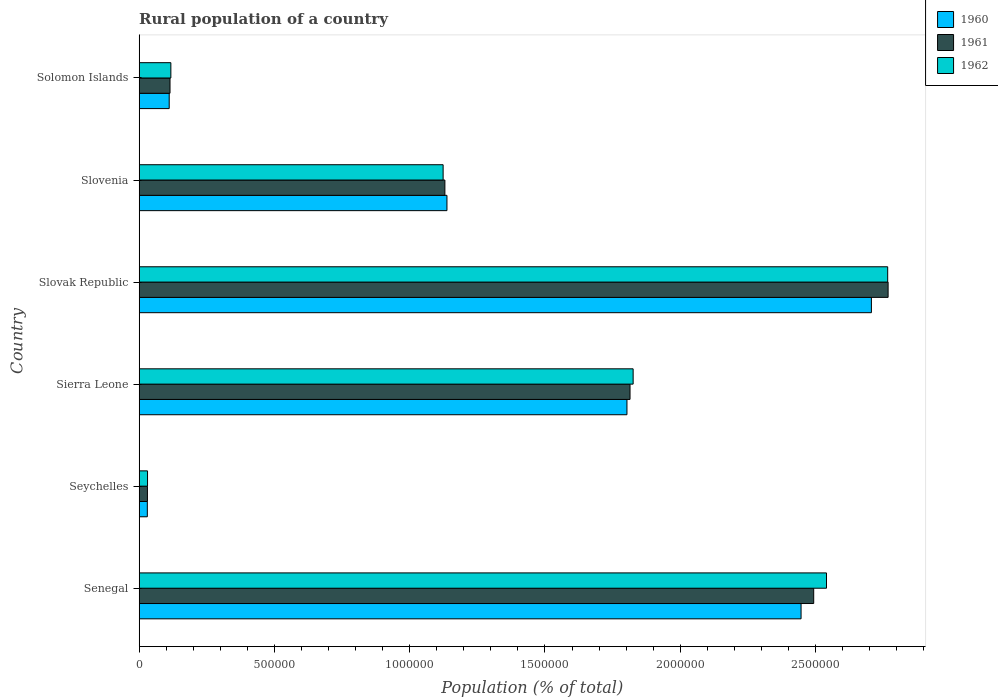Are the number of bars per tick equal to the number of legend labels?
Offer a very short reply. Yes. How many bars are there on the 1st tick from the top?
Your response must be concise. 3. How many bars are there on the 2nd tick from the bottom?
Provide a short and direct response. 3. What is the label of the 4th group of bars from the top?
Offer a terse response. Sierra Leone. What is the rural population in 1961 in Sierra Leone?
Make the answer very short. 1.81e+06. Across all countries, what is the maximum rural population in 1961?
Your response must be concise. 2.77e+06. Across all countries, what is the minimum rural population in 1960?
Provide a succinct answer. 3.02e+04. In which country was the rural population in 1961 maximum?
Your answer should be compact. Slovak Republic. In which country was the rural population in 1961 minimum?
Your response must be concise. Seychelles. What is the total rural population in 1961 in the graph?
Provide a short and direct response. 8.35e+06. What is the difference between the rural population in 1962 in Seychelles and that in Slovak Republic?
Provide a short and direct response. -2.74e+06. What is the difference between the rural population in 1961 in Slovak Republic and the rural population in 1962 in Solomon Islands?
Offer a very short reply. 2.65e+06. What is the average rural population in 1960 per country?
Your answer should be compact. 1.37e+06. What is the difference between the rural population in 1961 and rural population in 1962 in Sierra Leone?
Your answer should be very brief. -1.15e+04. In how many countries, is the rural population in 1960 greater than 2700000 %?
Your response must be concise. 1. What is the ratio of the rural population in 1961 in Seychelles to that in Sierra Leone?
Keep it short and to the point. 0.02. Is the rural population in 1961 in Senegal less than that in Slovenia?
Provide a succinct answer. No. Is the difference between the rural population in 1961 in Senegal and Solomon Islands greater than the difference between the rural population in 1962 in Senegal and Solomon Islands?
Offer a very short reply. No. What is the difference between the highest and the second highest rural population in 1961?
Your response must be concise. 2.75e+05. What is the difference between the highest and the lowest rural population in 1961?
Provide a succinct answer. 2.74e+06. In how many countries, is the rural population in 1961 greater than the average rural population in 1961 taken over all countries?
Your answer should be compact. 3. Is it the case that in every country, the sum of the rural population in 1961 and rural population in 1960 is greater than the rural population in 1962?
Make the answer very short. Yes. Are all the bars in the graph horizontal?
Provide a short and direct response. Yes. How many countries are there in the graph?
Make the answer very short. 6. What is the difference between two consecutive major ticks on the X-axis?
Your answer should be very brief. 5.00e+05. Does the graph contain grids?
Your response must be concise. No. Where does the legend appear in the graph?
Your answer should be compact. Top right. What is the title of the graph?
Your answer should be compact. Rural population of a country. What is the label or title of the X-axis?
Ensure brevity in your answer.  Population (% of total). What is the label or title of the Y-axis?
Your response must be concise. Country. What is the Population (% of total) of 1960 in Senegal?
Offer a terse response. 2.45e+06. What is the Population (% of total) in 1961 in Senegal?
Offer a very short reply. 2.49e+06. What is the Population (% of total) in 1962 in Senegal?
Provide a succinct answer. 2.54e+06. What is the Population (% of total) of 1960 in Seychelles?
Keep it short and to the point. 3.02e+04. What is the Population (% of total) of 1961 in Seychelles?
Ensure brevity in your answer.  3.06e+04. What is the Population (% of total) in 1962 in Seychelles?
Offer a very short reply. 3.09e+04. What is the Population (% of total) of 1960 in Sierra Leone?
Your answer should be very brief. 1.80e+06. What is the Population (% of total) in 1961 in Sierra Leone?
Your answer should be very brief. 1.81e+06. What is the Population (% of total) in 1962 in Sierra Leone?
Make the answer very short. 1.83e+06. What is the Population (% of total) in 1960 in Slovak Republic?
Offer a terse response. 2.71e+06. What is the Population (% of total) in 1961 in Slovak Republic?
Your answer should be compact. 2.77e+06. What is the Population (% of total) in 1962 in Slovak Republic?
Offer a terse response. 2.77e+06. What is the Population (% of total) of 1960 in Slovenia?
Make the answer very short. 1.14e+06. What is the Population (% of total) of 1961 in Slovenia?
Keep it short and to the point. 1.13e+06. What is the Population (% of total) in 1962 in Slovenia?
Provide a succinct answer. 1.12e+06. What is the Population (% of total) of 1960 in Solomon Islands?
Your answer should be compact. 1.11e+05. What is the Population (% of total) in 1961 in Solomon Islands?
Provide a short and direct response. 1.14e+05. What is the Population (% of total) of 1962 in Solomon Islands?
Give a very brief answer. 1.17e+05. Across all countries, what is the maximum Population (% of total) of 1960?
Give a very brief answer. 2.71e+06. Across all countries, what is the maximum Population (% of total) of 1961?
Make the answer very short. 2.77e+06. Across all countries, what is the maximum Population (% of total) of 1962?
Your answer should be compact. 2.77e+06. Across all countries, what is the minimum Population (% of total) in 1960?
Provide a short and direct response. 3.02e+04. Across all countries, what is the minimum Population (% of total) of 1961?
Offer a terse response. 3.06e+04. Across all countries, what is the minimum Population (% of total) of 1962?
Offer a very short reply. 3.09e+04. What is the total Population (% of total) in 1960 in the graph?
Offer a very short reply. 8.24e+06. What is the total Population (% of total) of 1961 in the graph?
Offer a very short reply. 8.35e+06. What is the total Population (% of total) in 1962 in the graph?
Your answer should be very brief. 8.41e+06. What is the difference between the Population (% of total) of 1960 in Senegal and that in Seychelles?
Provide a short and direct response. 2.42e+06. What is the difference between the Population (% of total) in 1961 in Senegal and that in Seychelles?
Offer a very short reply. 2.46e+06. What is the difference between the Population (% of total) of 1962 in Senegal and that in Seychelles?
Your answer should be compact. 2.51e+06. What is the difference between the Population (% of total) of 1960 in Senegal and that in Sierra Leone?
Your answer should be compact. 6.44e+05. What is the difference between the Population (% of total) in 1961 in Senegal and that in Sierra Leone?
Your answer should be compact. 6.79e+05. What is the difference between the Population (% of total) in 1962 in Senegal and that in Sierra Leone?
Your response must be concise. 7.15e+05. What is the difference between the Population (% of total) in 1960 in Senegal and that in Slovak Republic?
Offer a terse response. -2.60e+05. What is the difference between the Population (% of total) in 1961 in Senegal and that in Slovak Republic?
Offer a very short reply. -2.75e+05. What is the difference between the Population (% of total) in 1962 in Senegal and that in Slovak Republic?
Offer a terse response. -2.26e+05. What is the difference between the Population (% of total) in 1960 in Senegal and that in Slovenia?
Offer a very short reply. 1.31e+06. What is the difference between the Population (% of total) in 1961 in Senegal and that in Slovenia?
Provide a succinct answer. 1.36e+06. What is the difference between the Population (% of total) in 1962 in Senegal and that in Slovenia?
Offer a terse response. 1.42e+06. What is the difference between the Population (% of total) in 1960 in Senegal and that in Solomon Islands?
Provide a succinct answer. 2.34e+06. What is the difference between the Population (% of total) of 1961 in Senegal and that in Solomon Islands?
Give a very brief answer. 2.38e+06. What is the difference between the Population (% of total) of 1962 in Senegal and that in Solomon Islands?
Give a very brief answer. 2.42e+06. What is the difference between the Population (% of total) of 1960 in Seychelles and that in Sierra Leone?
Offer a terse response. -1.77e+06. What is the difference between the Population (% of total) in 1961 in Seychelles and that in Sierra Leone?
Your response must be concise. -1.78e+06. What is the difference between the Population (% of total) in 1962 in Seychelles and that in Sierra Leone?
Your answer should be very brief. -1.80e+06. What is the difference between the Population (% of total) of 1960 in Seychelles and that in Slovak Republic?
Your answer should be very brief. -2.68e+06. What is the difference between the Population (% of total) in 1961 in Seychelles and that in Slovak Republic?
Provide a short and direct response. -2.74e+06. What is the difference between the Population (% of total) in 1962 in Seychelles and that in Slovak Republic?
Your answer should be very brief. -2.74e+06. What is the difference between the Population (% of total) in 1960 in Seychelles and that in Slovenia?
Offer a terse response. -1.11e+06. What is the difference between the Population (% of total) in 1961 in Seychelles and that in Slovenia?
Your answer should be very brief. -1.10e+06. What is the difference between the Population (% of total) of 1962 in Seychelles and that in Slovenia?
Your answer should be compact. -1.09e+06. What is the difference between the Population (% of total) in 1960 in Seychelles and that in Solomon Islands?
Ensure brevity in your answer.  -8.09e+04. What is the difference between the Population (% of total) in 1961 in Seychelles and that in Solomon Islands?
Your answer should be compact. -8.35e+04. What is the difference between the Population (% of total) in 1962 in Seychelles and that in Solomon Islands?
Ensure brevity in your answer.  -8.62e+04. What is the difference between the Population (% of total) in 1960 in Sierra Leone and that in Slovak Republic?
Your answer should be very brief. -9.04e+05. What is the difference between the Population (% of total) in 1961 in Sierra Leone and that in Slovak Republic?
Provide a succinct answer. -9.54e+05. What is the difference between the Population (% of total) of 1962 in Sierra Leone and that in Slovak Republic?
Ensure brevity in your answer.  -9.41e+05. What is the difference between the Population (% of total) in 1960 in Sierra Leone and that in Slovenia?
Offer a terse response. 6.65e+05. What is the difference between the Population (% of total) of 1961 in Sierra Leone and that in Slovenia?
Your response must be concise. 6.84e+05. What is the difference between the Population (% of total) in 1962 in Sierra Leone and that in Slovenia?
Make the answer very short. 7.02e+05. What is the difference between the Population (% of total) of 1960 in Sierra Leone and that in Solomon Islands?
Your response must be concise. 1.69e+06. What is the difference between the Population (% of total) of 1961 in Sierra Leone and that in Solomon Islands?
Offer a terse response. 1.70e+06. What is the difference between the Population (% of total) in 1962 in Sierra Leone and that in Solomon Islands?
Ensure brevity in your answer.  1.71e+06. What is the difference between the Population (% of total) in 1960 in Slovak Republic and that in Slovenia?
Give a very brief answer. 1.57e+06. What is the difference between the Population (% of total) in 1961 in Slovak Republic and that in Slovenia?
Your response must be concise. 1.64e+06. What is the difference between the Population (% of total) in 1962 in Slovak Republic and that in Slovenia?
Provide a short and direct response. 1.64e+06. What is the difference between the Population (% of total) in 1960 in Slovak Republic and that in Solomon Islands?
Make the answer very short. 2.60e+06. What is the difference between the Population (% of total) of 1961 in Slovak Republic and that in Solomon Islands?
Make the answer very short. 2.65e+06. What is the difference between the Population (% of total) of 1962 in Slovak Republic and that in Solomon Islands?
Ensure brevity in your answer.  2.65e+06. What is the difference between the Population (% of total) of 1960 in Slovenia and that in Solomon Islands?
Provide a succinct answer. 1.03e+06. What is the difference between the Population (% of total) in 1961 in Slovenia and that in Solomon Islands?
Provide a short and direct response. 1.02e+06. What is the difference between the Population (% of total) in 1962 in Slovenia and that in Solomon Islands?
Keep it short and to the point. 1.01e+06. What is the difference between the Population (% of total) in 1960 in Senegal and the Population (% of total) in 1961 in Seychelles?
Your answer should be compact. 2.42e+06. What is the difference between the Population (% of total) in 1960 in Senegal and the Population (% of total) in 1962 in Seychelles?
Keep it short and to the point. 2.42e+06. What is the difference between the Population (% of total) of 1961 in Senegal and the Population (% of total) of 1962 in Seychelles?
Keep it short and to the point. 2.46e+06. What is the difference between the Population (% of total) in 1960 in Senegal and the Population (% of total) in 1961 in Sierra Leone?
Keep it short and to the point. 6.32e+05. What is the difference between the Population (% of total) of 1960 in Senegal and the Population (% of total) of 1962 in Sierra Leone?
Offer a very short reply. 6.21e+05. What is the difference between the Population (% of total) in 1961 in Senegal and the Population (% of total) in 1962 in Sierra Leone?
Your answer should be compact. 6.67e+05. What is the difference between the Population (% of total) of 1960 in Senegal and the Population (% of total) of 1961 in Slovak Republic?
Your response must be concise. -3.22e+05. What is the difference between the Population (% of total) of 1960 in Senegal and the Population (% of total) of 1962 in Slovak Republic?
Give a very brief answer. -3.20e+05. What is the difference between the Population (% of total) of 1961 in Senegal and the Population (% of total) of 1962 in Slovak Republic?
Ensure brevity in your answer.  -2.74e+05. What is the difference between the Population (% of total) in 1960 in Senegal and the Population (% of total) in 1961 in Slovenia?
Your answer should be compact. 1.32e+06. What is the difference between the Population (% of total) in 1960 in Senegal and the Population (% of total) in 1962 in Slovenia?
Make the answer very short. 1.32e+06. What is the difference between the Population (% of total) of 1961 in Senegal and the Population (% of total) of 1962 in Slovenia?
Offer a very short reply. 1.37e+06. What is the difference between the Population (% of total) in 1960 in Senegal and the Population (% of total) in 1961 in Solomon Islands?
Provide a succinct answer. 2.33e+06. What is the difference between the Population (% of total) in 1960 in Senegal and the Population (% of total) in 1962 in Solomon Islands?
Provide a short and direct response. 2.33e+06. What is the difference between the Population (% of total) in 1961 in Senegal and the Population (% of total) in 1962 in Solomon Islands?
Provide a short and direct response. 2.38e+06. What is the difference between the Population (% of total) of 1960 in Seychelles and the Population (% of total) of 1961 in Sierra Leone?
Keep it short and to the point. -1.78e+06. What is the difference between the Population (% of total) of 1960 in Seychelles and the Population (% of total) of 1962 in Sierra Leone?
Your answer should be compact. -1.80e+06. What is the difference between the Population (% of total) in 1961 in Seychelles and the Population (% of total) in 1962 in Sierra Leone?
Offer a very short reply. -1.80e+06. What is the difference between the Population (% of total) of 1960 in Seychelles and the Population (% of total) of 1961 in Slovak Republic?
Ensure brevity in your answer.  -2.74e+06. What is the difference between the Population (% of total) in 1960 in Seychelles and the Population (% of total) in 1962 in Slovak Republic?
Offer a very short reply. -2.74e+06. What is the difference between the Population (% of total) of 1961 in Seychelles and the Population (% of total) of 1962 in Slovak Republic?
Offer a terse response. -2.74e+06. What is the difference between the Population (% of total) in 1960 in Seychelles and the Population (% of total) in 1961 in Slovenia?
Offer a terse response. -1.10e+06. What is the difference between the Population (% of total) of 1960 in Seychelles and the Population (% of total) of 1962 in Slovenia?
Your response must be concise. -1.09e+06. What is the difference between the Population (% of total) of 1961 in Seychelles and the Population (% of total) of 1962 in Slovenia?
Offer a terse response. -1.09e+06. What is the difference between the Population (% of total) in 1960 in Seychelles and the Population (% of total) in 1961 in Solomon Islands?
Your answer should be compact. -8.39e+04. What is the difference between the Population (% of total) of 1960 in Seychelles and the Population (% of total) of 1962 in Solomon Islands?
Offer a terse response. -8.70e+04. What is the difference between the Population (% of total) in 1961 in Seychelles and the Population (% of total) in 1962 in Solomon Islands?
Your response must be concise. -8.66e+04. What is the difference between the Population (% of total) of 1960 in Sierra Leone and the Population (% of total) of 1961 in Slovak Republic?
Offer a very short reply. -9.65e+05. What is the difference between the Population (% of total) in 1960 in Sierra Leone and the Population (% of total) in 1962 in Slovak Republic?
Provide a short and direct response. -9.64e+05. What is the difference between the Population (% of total) of 1961 in Sierra Leone and the Population (% of total) of 1962 in Slovak Republic?
Give a very brief answer. -9.52e+05. What is the difference between the Population (% of total) in 1960 in Sierra Leone and the Population (% of total) in 1961 in Slovenia?
Provide a short and direct response. 6.73e+05. What is the difference between the Population (% of total) in 1960 in Sierra Leone and the Population (% of total) in 1962 in Slovenia?
Give a very brief answer. 6.80e+05. What is the difference between the Population (% of total) of 1961 in Sierra Leone and the Population (% of total) of 1962 in Slovenia?
Offer a terse response. 6.91e+05. What is the difference between the Population (% of total) in 1960 in Sierra Leone and the Population (% of total) in 1961 in Solomon Islands?
Provide a short and direct response. 1.69e+06. What is the difference between the Population (% of total) in 1960 in Sierra Leone and the Population (% of total) in 1962 in Solomon Islands?
Your answer should be compact. 1.69e+06. What is the difference between the Population (% of total) of 1961 in Sierra Leone and the Population (% of total) of 1962 in Solomon Islands?
Your answer should be compact. 1.70e+06. What is the difference between the Population (% of total) in 1960 in Slovak Republic and the Population (% of total) in 1961 in Slovenia?
Ensure brevity in your answer.  1.58e+06. What is the difference between the Population (% of total) of 1960 in Slovak Republic and the Population (% of total) of 1962 in Slovenia?
Provide a succinct answer. 1.58e+06. What is the difference between the Population (% of total) in 1961 in Slovak Republic and the Population (% of total) in 1962 in Slovenia?
Your response must be concise. 1.64e+06. What is the difference between the Population (% of total) in 1960 in Slovak Republic and the Population (% of total) in 1961 in Solomon Islands?
Your response must be concise. 2.59e+06. What is the difference between the Population (% of total) in 1960 in Slovak Republic and the Population (% of total) in 1962 in Solomon Islands?
Provide a succinct answer. 2.59e+06. What is the difference between the Population (% of total) in 1961 in Slovak Republic and the Population (% of total) in 1962 in Solomon Islands?
Your answer should be compact. 2.65e+06. What is the difference between the Population (% of total) of 1960 in Slovenia and the Population (% of total) of 1961 in Solomon Islands?
Give a very brief answer. 1.02e+06. What is the difference between the Population (% of total) of 1960 in Slovenia and the Population (% of total) of 1962 in Solomon Islands?
Offer a terse response. 1.02e+06. What is the difference between the Population (% of total) of 1961 in Slovenia and the Population (% of total) of 1962 in Solomon Islands?
Your response must be concise. 1.01e+06. What is the average Population (% of total) in 1960 per country?
Offer a very short reply. 1.37e+06. What is the average Population (% of total) of 1961 per country?
Provide a short and direct response. 1.39e+06. What is the average Population (% of total) in 1962 per country?
Offer a very short reply. 1.40e+06. What is the difference between the Population (% of total) in 1960 and Population (% of total) in 1961 in Senegal?
Offer a very short reply. -4.67e+04. What is the difference between the Population (% of total) in 1960 and Population (% of total) in 1962 in Senegal?
Your answer should be compact. -9.40e+04. What is the difference between the Population (% of total) of 1961 and Population (% of total) of 1962 in Senegal?
Your response must be concise. -4.73e+04. What is the difference between the Population (% of total) of 1960 and Population (% of total) of 1961 in Seychelles?
Offer a very short reply. -413. What is the difference between the Population (% of total) in 1960 and Population (% of total) in 1962 in Seychelles?
Your answer should be very brief. -764. What is the difference between the Population (% of total) of 1961 and Population (% of total) of 1962 in Seychelles?
Ensure brevity in your answer.  -351. What is the difference between the Population (% of total) of 1960 and Population (% of total) of 1961 in Sierra Leone?
Your response must be concise. -1.14e+04. What is the difference between the Population (% of total) in 1960 and Population (% of total) in 1962 in Sierra Leone?
Keep it short and to the point. -2.29e+04. What is the difference between the Population (% of total) in 1961 and Population (% of total) in 1962 in Sierra Leone?
Your answer should be very brief. -1.15e+04. What is the difference between the Population (% of total) in 1960 and Population (% of total) in 1961 in Slovak Republic?
Your answer should be very brief. -6.17e+04. What is the difference between the Population (% of total) in 1960 and Population (% of total) in 1962 in Slovak Republic?
Provide a succinct answer. -6.02e+04. What is the difference between the Population (% of total) of 1961 and Population (% of total) of 1962 in Slovak Republic?
Keep it short and to the point. 1527. What is the difference between the Population (% of total) of 1960 and Population (% of total) of 1961 in Slovenia?
Ensure brevity in your answer.  7639. What is the difference between the Population (% of total) in 1960 and Population (% of total) in 1962 in Slovenia?
Provide a short and direct response. 1.42e+04. What is the difference between the Population (% of total) of 1961 and Population (% of total) of 1962 in Slovenia?
Ensure brevity in your answer.  6514. What is the difference between the Population (% of total) of 1960 and Population (% of total) of 1961 in Solomon Islands?
Your response must be concise. -3003. What is the difference between the Population (% of total) in 1960 and Population (% of total) in 1962 in Solomon Islands?
Your answer should be compact. -6092. What is the difference between the Population (% of total) in 1961 and Population (% of total) in 1962 in Solomon Islands?
Provide a short and direct response. -3089. What is the ratio of the Population (% of total) of 1960 in Senegal to that in Seychelles?
Offer a very short reply. 81.12. What is the ratio of the Population (% of total) in 1961 in Senegal to that in Seychelles?
Keep it short and to the point. 81.56. What is the ratio of the Population (% of total) of 1962 in Senegal to that in Seychelles?
Provide a short and direct response. 82.16. What is the ratio of the Population (% of total) of 1960 in Senegal to that in Sierra Leone?
Offer a terse response. 1.36. What is the ratio of the Population (% of total) in 1961 in Senegal to that in Sierra Leone?
Make the answer very short. 1.37. What is the ratio of the Population (% of total) in 1962 in Senegal to that in Sierra Leone?
Provide a succinct answer. 1.39. What is the ratio of the Population (% of total) in 1960 in Senegal to that in Slovak Republic?
Ensure brevity in your answer.  0.9. What is the ratio of the Population (% of total) in 1961 in Senegal to that in Slovak Republic?
Your response must be concise. 0.9. What is the ratio of the Population (% of total) of 1962 in Senegal to that in Slovak Republic?
Your response must be concise. 0.92. What is the ratio of the Population (% of total) of 1960 in Senegal to that in Slovenia?
Make the answer very short. 2.15. What is the ratio of the Population (% of total) of 1961 in Senegal to that in Slovenia?
Offer a very short reply. 2.21. What is the ratio of the Population (% of total) in 1962 in Senegal to that in Slovenia?
Offer a terse response. 2.26. What is the ratio of the Population (% of total) in 1960 in Senegal to that in Solomon Islands?
Your answer should be compact. 22.03. What is the ratio of the Population (% of total) in 1961 in Senegal to that in Solomon Islands?
Your response must be concise. 21.86. What is the ratio of the Population (% of total) in 1962 in Senegal to that in Solomon Islands?
Your answer should be compact. 21.69. What is the ratio of the Population (% of total) of 1960 in Seychelles to that in Sierra Leone?
Ensure brevity in your answer.  0.02. What is the ratio of the Population (% of total) of 1961 in Seychelles to that in Sierra Leone?
Give a very brief answer. 0.02. What is the ratio of the Population (% of total) of 1962 in Seychelles to that in Sierra Leone?
Your response must be concise. 0.02. What is the ratio of the Population (% of total) of 1960 in Seychelles to that in Slovak Republic?
Provide a succinct answer. 0.01. What is the ratio of the Population (% of total) in 1961 in Seychelles to that in Slovak Republic?
Offer a very short reply. 0.01. What is the ratio of the Population (% of total) in 1962 in Seychelles to that in Slovak Republic?
Make the answer very short. 0.01. What is the ratio of the Population (% of total) in 1960 in Seychelles to that in Slovenia?
Your answer should be compact. 0.03. What is the ratio of the Population (% of total) in 1961 in Seychelles to that in Slovenia?
Make the answer very short. 0.03. What is the ratio of the Population (% of total) of 1962 in Seychelles to that in Slovenia?
Your response must be concise. 0.03. What is the ratio of the Population (% of total) of 1960 in Seychelles to that in Solomon Islands?
Give a very brief answer. 0.27. What is the ratio of the Population (% of total) in 1961 in Seychelles to that in Solomon Islands?
Keep it short and to the point. 0.27. What is the ratio of the Population (% of total) in 1962 in Seychelles to that in Solomon Islands?
Your answer should be compact. 0.26. What is the ratio of the Population (% of total) of 1960 in Sierra Leone to that in Slovak Republic?
Provide a short and direct response. 0.67. What is the ratio of the Population (% of total) in 1961 in Sierra Leone to that in Slovak Republic?
Your answer should be compact. 0.66. What is the ratio of the Population (% of total) in 1962 in Sierra Leone to that in Slovak Republic?
Provide a succinct answer. 0.66. What is the ratio of the Population (% of total) of 1960 in Sierra Leone to that in Slovenia?
Your response must be concise. 1.58. What is the ratio of the Population (% of total) of 1961 in Sierra Leone to that in Slovenia?
Offer a very short reply. 1.61. What is the ratio of the Population (% of total) in 1962 in Sierra Leone to that in Slovenia?
Your response must be concise. 1.63. What is the ratio of the Population (% of total) in 1960 in Sierra Leone to that in Solomon Islands?
Provide a short and direct response. 16.23. What is the ratio of the Population (% of total) of 1961 in Sierra Leone to that in Solomon Islands?
Ensure brevity in your answer.  15.91. What is the ratio of the Population (% of total) of 1962 in Sierra Leone to that in Solomon Islands?
Ensure brevity in your answer.  15.59. What is the ratio of the Population (% of total) of 1960 in Slovak Republic to that in Slovenia?
Offer a very short reply. 2.38. What is the ratio of the Population (% of total) in 1961 in Slovak Republic to that in Slovenia?
Your answer should be very brief. 2.45. What is the ratio of the Population (% of total) in 1962 in Slovak Republic to that in Slovenia?
Offer a very short reply. 2.46. What is the ratio of the Population (% of total) of 1960 in Slovak Republic to that in Solomon Islands?
Offer a terse response. 24.37. What is the ratio of the Population (% of total) of 1961 in Slovak Republic to that in Solomon Islands?
Your response must be concise. 24.27. What is the ratio of the Population (% of total) in 1962 in Slovak Republic to that in Solomon Islands?
Your answer should be compact. 23.62. What is the ratio of the Population (% of total) of 1960 in Slovenia to that in Solomon Islands?
Provide a succinct answer. 10.24. What is the ratio of the Population (% of total) of 1961 in Slovenia to that in Solomon Islands?
Provide a succinct answer. 9.91. What is the ratio of the Population (% of total) of 1962 in Slovenia to that in Solomon Islands?
Make the answer very short. 9.59. What is the difference between the highest and the second highest Population (% of total) in 1960?
Offer a very short reply. 2.60e+05. What is the difference between the highest and the second highest Population (% of total) in 1961?
Keep it short and to the point. 2.75e+05. What is the difference between the highest and the second highest Population (% of total) in 1962?
Your answer should be compact. 2.26e+05. What is the difference between the highest and the lowest Population (% of total) of 1960?
Your response must be concise. 2.68e+06. What is the difference between the highest and the lowest Population (% of total) in 1961?
Your answer should be compact. 2.74e+06. What is the difference between the highest and the lowest Population (% of total) in 1962?
Offer a very short reply. 2.74e+06. 